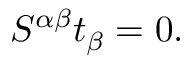<formula> <loc_0><loc_0><loc_500><loc_500>S ^ { \alpha \beta } t _ { \beta } = 0 .</formula> 